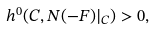<formula> <loc_0><loc_0><loc_500><loc_500>h ^ { 0 } ( C , N ( - F ) | _ { C } ) > 0 ,</formula> 